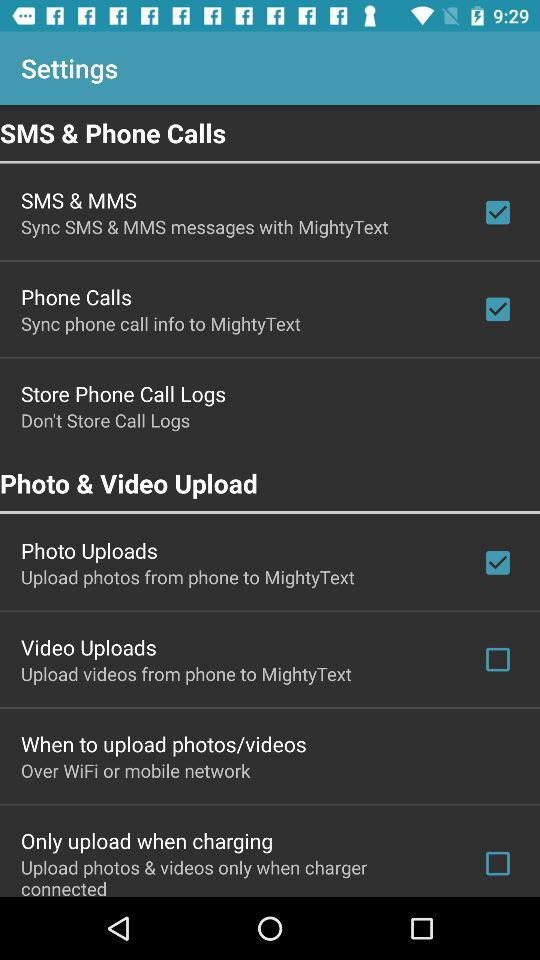What is the status of "Photo Uploads"? The status of "Photo Uploads" is "on". 